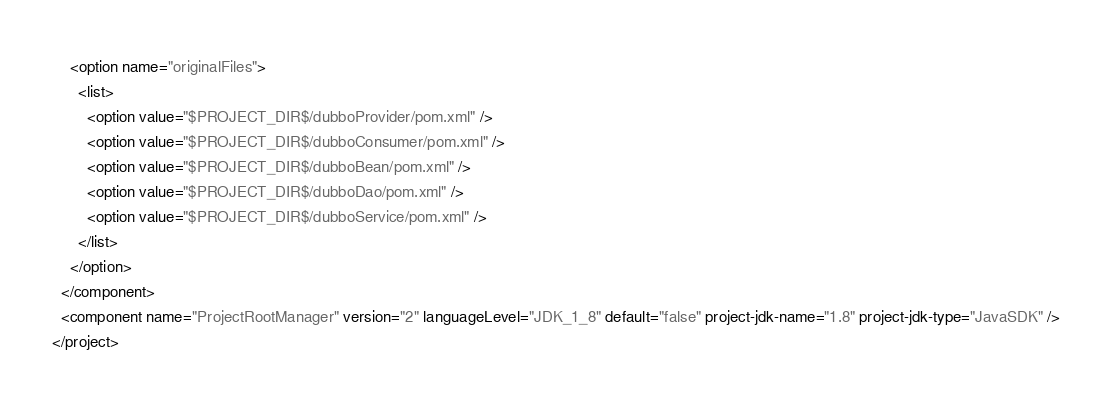<code> <loc_0><loc_0><loc_500><loc_500><_XML_>    <option name="originalFiles">
      <list>
        <option value="$PROJECT_DIR$/dubboProvider/pom.xml" />
        <option value="$PROJECT_DIR$/dubboConsumer/pom.xml" />
        <option value="$PROJECT_DIR$/dubboBean/pom.xml" />
        <option value="$PROJECT_DIR$/dubboDao/pom.xml" />
        <option value="$PROJECT_DIR$/dubboService/pom.xml" />
      </list>
    </option>
  </component>
  <component name="ProjectRootManager" version="2" languageLevel="JDK_1_8" default="false" project-jdk-name="1.8" project-jdk-type="JavaSDK" />
</project></code> 